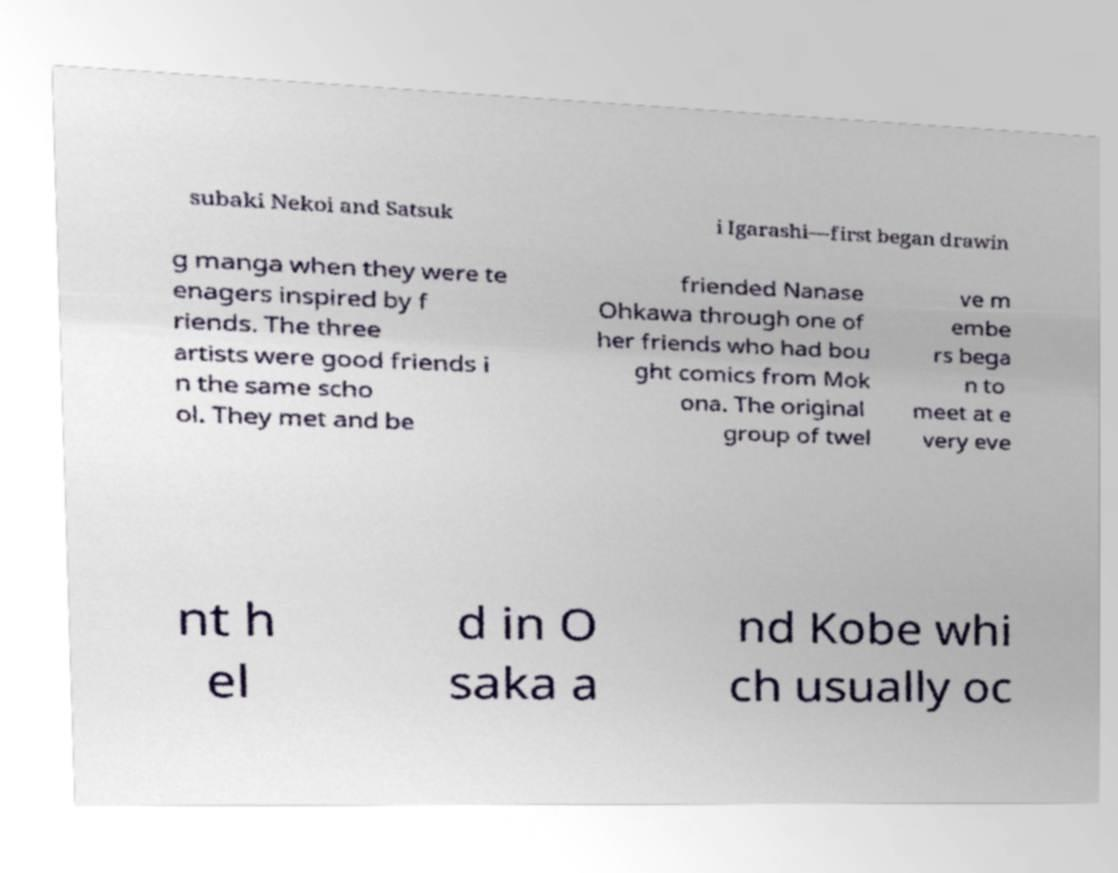I need the written content from this picture converted into text. Can you do that? subaki Nekoi and Satsuk i Igarashi—first began drawin g manga when they were te enagers inspired by f riends. The three artists were good friends i n the same scho ol. They met and be friended Nanase Ohkawa through one of her friends who had bou ght comics from Mok ona. The original group of twel ve m embe rs bega n to meet at e very eve nt h el d in O saka a nd Kobe whi ch usually oc 